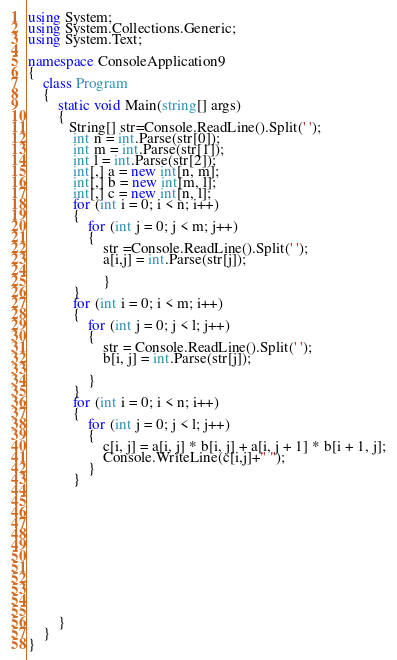Convert code to text. <code><loc_0><loc_0><loc_500><loc_500><_C#_>using System;
using System.Collections.Generic;
using System.Text;

namespace ConsoleApplication9
{
    class Program
    {
        static void Main(string[] args)
        {
           String[] str=Console.ReadLine().Split(' ');
            int n = int.Parse(str[0]);
            int m = int.Parse(str[1]);
            int l = int.Parse(str[2]);
            int[,] a = new int[n, m];
            int[,] b = new int[m, l];
            int[,] c = new int[n, l];
            for (int i = 0; i < n; i++)
            {
                for (int j = 0; j < m; j++)
                {
                    str =Console.ReadLine().Split(' ');
                    a[i,j] = int.Parse(str[j]);
 
                    }
            }
            for (int i = 0; i < m; i++)
            {
                for (int j = 0; j < l; j++)
                {
                    str = Console.ReadLine().Split(' ');
                    b[i, j] = int.Parse(str[j]);

                }
            }
            for (int i = 0; i < n; i++)
            {
                for (int j = 0; j < l; j++)
                {
                    c[i, j] = a[i, j] * b[i, j] + a[i, j + 1] * b[i + 1, j];
                    Console.WriteLine(c[i,j]+" ");
                }
            }
          

            




            
        
        
         

        }
    }
}</code> 